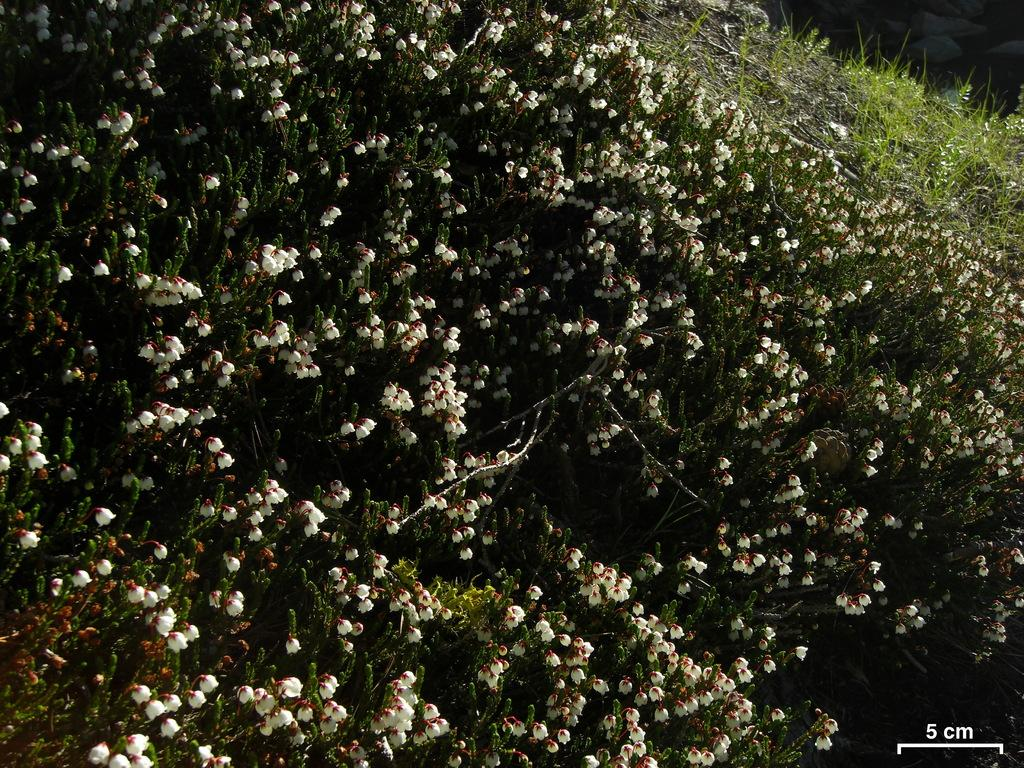What type of plants can be seen in the image? There are plants with flowers in the image. What is covering the ground in the image? There is grass visible on the ground in the image. Is there any additional information provided in the image? Yes, there is a measurement in the bottom right corner of the image. What type of straw is used to create the flowers in the image? There is no straw present in the image; the flowers are part of the plants themselves. 